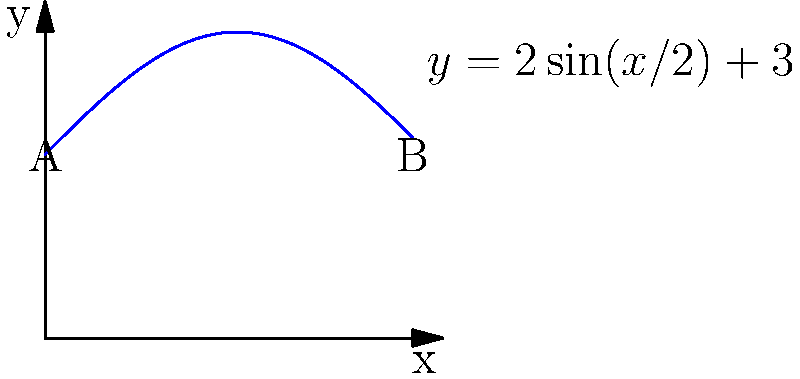At the farmers' market, you have an irregularly shaped plot of land for organic produce. The plot's boundary can be modeled by the function $y = 2\sin(x/2) + 3$ from $x = 0$ to $x = 6$ (in meters). Calculate the area of this plot using integration. To find the area of the irregularly shaped plot, we need to integrate the function from $x = 0$ to $x = 6$. Here's how we do it step by step:

1) The area under a curve is given by the definite integral:

   $$A = \int_a^b f(x) dx$$

2) In this case, $f(x) = 2\sin(x/2) + 3$, $a = 0$, and $b = 6$. So our integral becomes:

   $$A = \int_0^6 (2\sin(x/2) + 3) dx$$

3) Let's split this into two integrals:

   $$A = \int_0^6 2\sin(x/2) dx + \int_0^6 3 dx$$

4) For the first integral, we can use the substitution $u = x/2$, $du = dx/2$, $dx = 2du$:

   $$\int_0^6 2\sin(x/2) dx = 4\int_0^3 \sin(u) du = -4\cos(u)|_0^3 = -4(\cos(3) - \cos(0)) = -4(\cos(3) - 1)$$

5) The second integral is straightforward:

   $$\int_0^6 3 dx = 3x|_0^6 = 18$$

6) Adding these together:

   $$A = -4(\cos(3) - 1) + 18 = -4\cos(3) + 22$$

7) This gives us the exact answer. If we need a decimal approximation:

   $$A \approx 21.0175 \text{ square meters}$$
Answer: $-4\cos(3) + 22$ square meters 